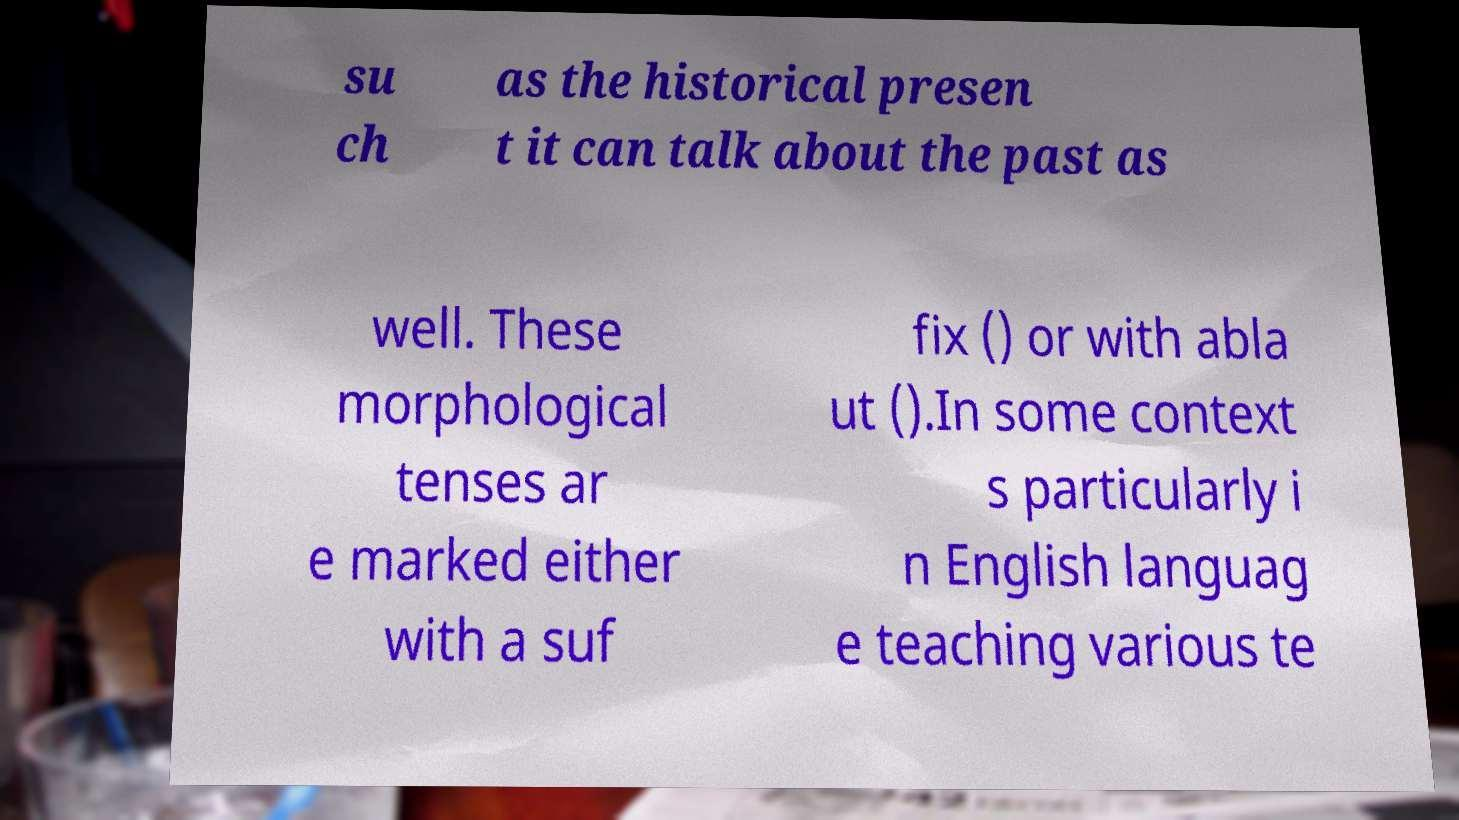Could you extract and type out the text from this image? su ch as the historical presen t it can talk about the past as well. These morphological tenses ar e marked either with a suf fix () or with abla ut ().In some context s particularly i n English languag e teaching various te 